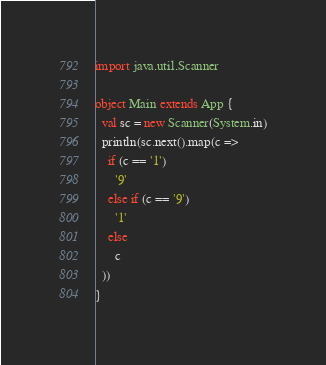<code> <loc_0><loc_0><loc_500><loc_500><_Scala_>
import java.util.Scanner

object Main extends App {
  val sc = new Scanner(System.in)
  println(sc.next().map(c =>
    if (c == '1')
      '9'
    else if (c == '9')
      '1'
    else
      c
  ))
}
</code> 